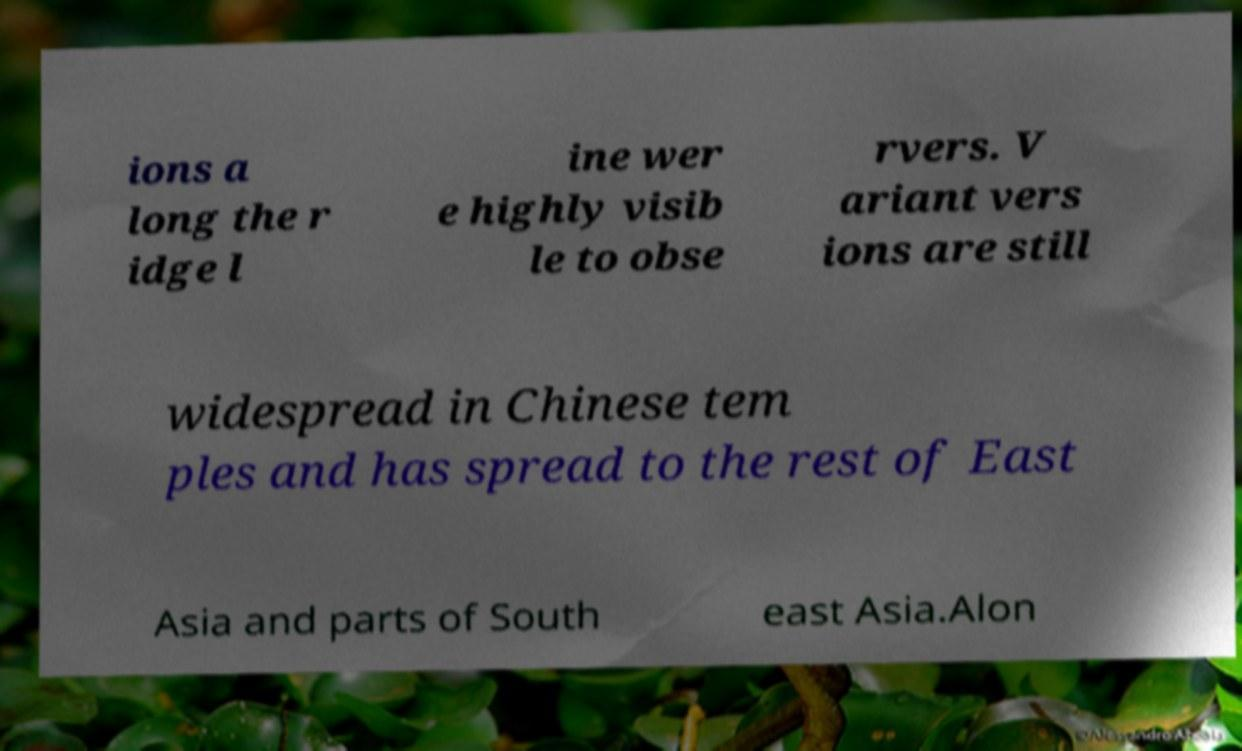Please identify and transcribe the text found in this image. ions a long the r idge l ine wer e highly visib le to obse rvers. V ariant vers ions are still widespread in Chinese tem ples and has spread to the rest of East Asia and parts of South east Asia.Alon 